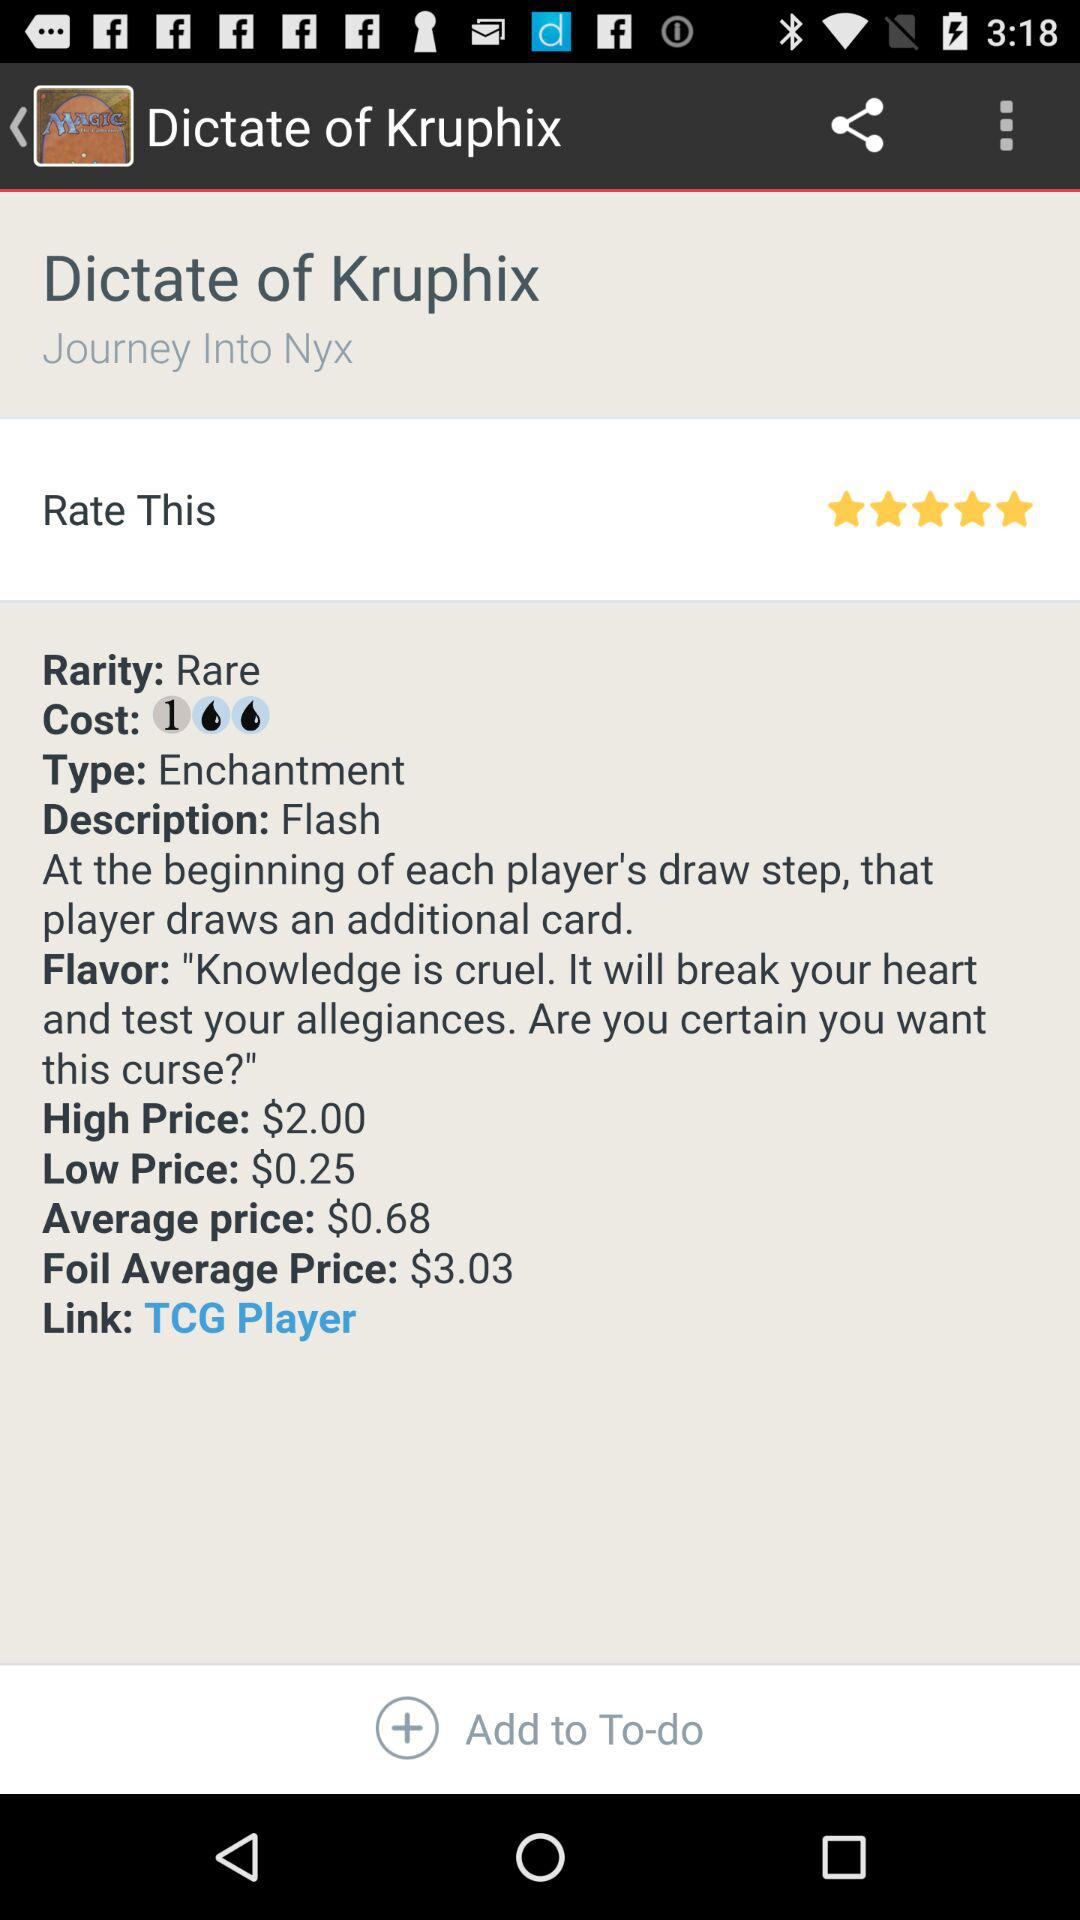What is the low price? The low price is $0.25. 